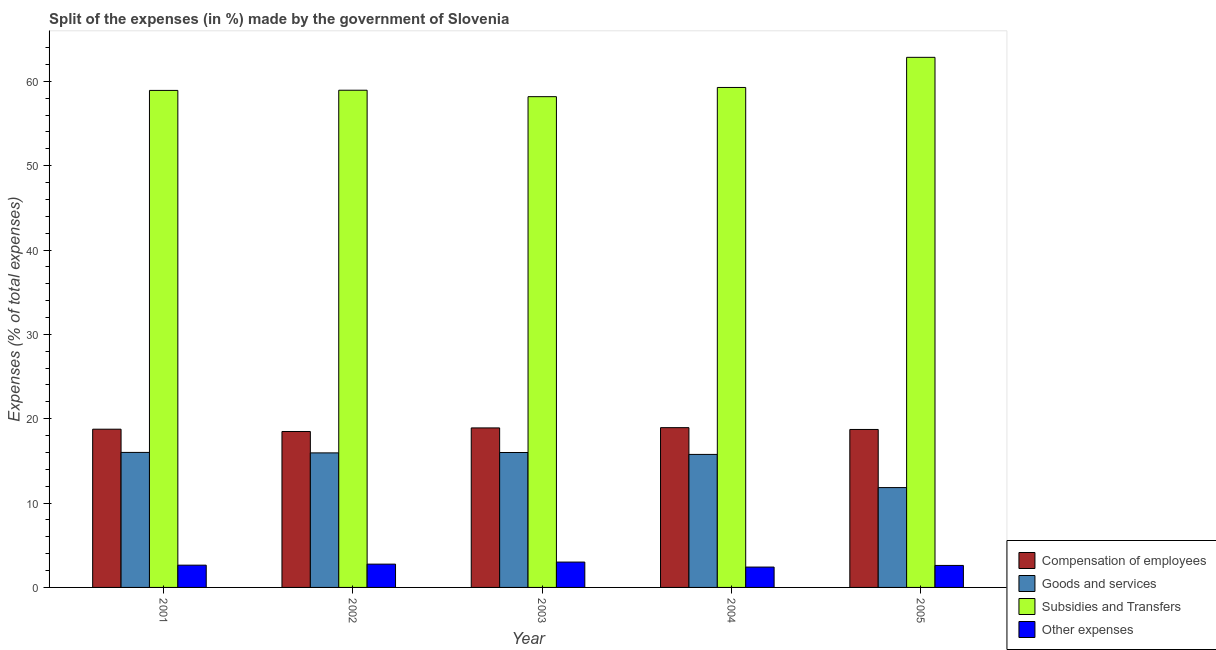Are the number of bars per tick equal to the number of legend labels?
Give a very brief answer. Yes. How many bars are there on the 1st tick from the left?
Your response must be concise. 4. What is the percentage of amount spent on compensation of employees in 2005?
Offer a terse response. 18.73. Across all years, what is the maximum percentage of amount spent on compensation of employees?
Provide a short and direct response. 18.94. Across all years, what is the minimum percentage of amount spent on compensation of employees?
Keep it short and to the point. 18.49. In which year was the percentage of amount spent on other expenses minimum?
Your answer should be very brief. 2004. What is the total percentage of amount spent on goods and services in the graph?
Make the answer very short. 75.55. What is the difference between the percentage of amount spent on other expenses in 2002 and that in 2003?
Provide a succinct answer. -0.24. What is the difference between the percentage of amount spent on compensation of employees in 2005 and the percentage of amount spent on subsidies in 2004?
Ensure brevity in your answer.  -0.21. What is the average percentage of amount spent on subsidies per year?
Give a very brief answer. 59.63. In the year 2002, what is the difference between the percentage of amount spent on subsidies and percentage of amount spent on compensation of employees?
Your response must be concise. 0. What is the ratio of the percentage of amount spent on other expenses in 2003 to that in 2005?
Offer a very short reply. 1.15. Is the percentage of amount spent on goods and services in 2001 less than that in 2004?
Your answer should be very brief. No. Is the difference between the percentage of amount spent on other expenses in 2001 and 2004 greater than the difference between the percentage of amount spent on subsidies in 2001 and 2004?
Your answer should be very brief. No. What is the difference between the highest and the second highest percentage of amount spent on goods and services?
Your answer should be very brief. 0.01. What is the difference between the highest and the lowest percentage of amount spent on compensation of employees?
Ensure brevity in your answer.  0.45. In how many years, is the percentage of amount spent on other expenses greater than the average percentage of amount spent on other expenses taken over all years?
Your answer should be compact. 2. What does the 2nd bar from the left in 2001 represents?
Make the answer very short. Goods and services. What does the 4th bar from the right in 2001 represents?
Provide a short and direct response. Compensation of employees. Is it the case that in every year, the sum of the percentage of amount spent on compensation of employees and percentage of amount spent on goods and services is greater than the percentage of amount spent on subsidies?
Offer a very short reply. No. How many bars are there?
Give a very brief answer. 20. Are all the bars in the graph horizontal?
Provide a succinct answer. No. How many years are there in the graph?
Keep it short and to the point. 5. Are the values on the major ticks of Y-axis written in scientific E-notation?
Offer a terse response. No. Where does the legend appear in the graph?
Your response must be concise. Bottom right. What is the title of the graph?
Offer a terse response. Split of the expenses (in %) made by the government of Slovenia. Does "Tertiary education" appear as one of the legend labels in the graph?
Ensure brevity in your answer.  No. What is the label or title of the X-axis?
Keep it short and to the point. Year. What is the label or title of the Y-axis?
Offer a very short reply. Expenses (% of total expenses). What is the Expenses (% of total expenses) in Compensation of employees in 2001?
Your answer should be compact. 18.76. What is the Expenses (% of total expenses) in Goods and services in 2001?
Your response must be concise. 16.01. What is the Expenses (% of total expenses) in Subsidies and Transfers in 2001?
Your answer should be compact. 58.92. What is the Expenses (% of total expenses) of Other expenses in 2001?
Offer a terse response. 2.64. What is the Expenses (% of total expenses) of Compensation of employees in 2002?
Keep it short and to the point. 18.49. What is the Expenses (% of total expenses) of Goods and services in 2002?
Provide a short and direct response. 15.95. What is the Expenses (% of total expenses) in Subsidies and Transfers in 2002?
Offer a terse response. 58.94. What is the Expenses (% of total expenses) in Other expenses in 2002?
Make the answer very short. 2.76. What is the Expenses (% of total expenses) in Compensation of employees in 2003?
Keep it short and to the point. 18.91. What is the Expenses (% of total expenses) in Goods and services in 2003?
Your response must be concise. 15.99. What is the Expenses (% of total expenses) of Subsidies and Transfers in 2003?
Offer a terse response. 58.18. What is the Expenses (% of total expenses) in Other expenses in 2003?
Your answer should be very brief. 3.01. What is the Expenses (% of total expenses) of Compensation of employees in 2004?
Offer a terse response. 18.94. What is the Expenses (% of total expenses) in Goods and services in 2004?
Provide a succinct answer. 15.77. What is the Expenses (% of total expenses) in Subsidies and Transfers in 2004?
Provide a short and direct response. 59.27. What is the Expenses (% of total expenses) of Other expenses in 2004?
Provide a succinct answer. 2.41. What is the Expenses (% of total expenses) of Compensation of employees in 2005?
Make the answer very short. 18.73. What is the Expenses (% of total expenses) in Goods and services in 2005?
Your answer should be very brief. 11.83. What is the Expenses (% of total expenses) in Subsidies and Transfers in 2005?
Your answer should be compact. 62.84. What is the Expenses (% of total expenses) of Other expenses in 2005?
Offer a terse response. 2.61. Across all years, what is the maximum Expenses (% of total expenses) of Compensation of employees?
Keep it short and to the point. 18.94. Across all years, what is the maximum Expenses (% of total expenses) in Goods and services?
Offer a terse response. 16.01. Across all years, what is the maximum Expenses (% of total expenses) in Subsidies and Transfers?
Your answer should be compact. 62.84. Across all years, what is the maximum Expenses (% of total expenses) in Other expenses?
Ensure brevity in your answer.  3.01. Across all years, what is the minimum Expenses (% of total expenses) in Compensation of employees?
Your answer should be compact. 18.49. Across all years, what is the minimum Expenses (% of total expenses) of Goods and services?
Make the answer very short. 11.83. Across all years, what is the minimum Expenses (% of total expenses) in Subsidies and Transfers?
Offer a very short reply. 58.18. Across all years, what is the minimum Expenses (% of total expenses) in Other expenses?
Offer a terse response. 2.41. What is the total Expenses (% of total expenses) of Compensation of employees in the graph?
Your response must be concise. 93.82. What is the total Expenses (% of total expenses) of Goods and services in the graph?
Ensure brevity in your answer.  75.55. What is the total Expenses (% of total expenses) of Subsidies and Transfers in the graph?
Make the answer very short. 298.15. What is the total Expenses (% of total expenses) in Other expenses in the graph?
Give a very brief answer. 13.43. What is the difference between the Expenses (% of total expenses) of Compensation of employees in 2001 and that in 2002?
Ensure brevity in your answer.  0.27. What is the difference between the Expenses (% of total expenses) of Goods and services in 2001 and that in 2002?
Your answer should be very brief. 0.06. What is the difference between the Expenses (% of total expenses) of Subsidies and Transfers in 2001 and that in 2002?
Make the answer very short. -0.02. What is the difference between the Expenses (% of total expenses) of Other expenses in 2001 and that in 2002?
Provide a short and direct response. -0.12. What is the difference between the Expenses (% of total expenses) in Compensation of employees in 2001 and that in 2003?
Make the answer very short. -0.15. What is the difference between the Expenses (% of total expenses) in Goods and services in 2001 and that in 2003?
Your response must be concise. 0.01. What is the difference between the Expenses (% of total expenses) of Subsidies and Transfers in 2001 and that in 2003?
Your response must be concise. 0.74. What is the difference between the Expenses (% of total expenses) in Other expenses in 2001 and that in 2003?
Make the answer very short. -0.37. What is the difference between the Expenses (% of total expenses) of Compensation of employees in 2001 and that in 2004?
Offer a very short reply. -0.18. What is the difference between the Expenses (% of total expenses) in Goods and services in 2001 and that in 2004?
Your answer should be very brief. 0.24. What is the difference between the Expenses (% of total expenses) in Subsidies and Transfers in 2001 and that in 2004?
Your response must be concise. -0.35. What is the difference between the Expenses (% of total expenses) of Other expenses in 2001 and that in 2004?
Offer a terse response. 0.22. What is the difference between the Expenses (% of total expenses) in Compensation of employees in 2001 and that in 2005?
Give a very brief answer. 0.03. What is the difference between the Expenses (% of total expenses) of Goods and services in 2001 and that in 2005?
Give a very brief answer. 4.17. What is the difference between the Expenses (% of total expenses) in Subsidies and Transfers in 2001 and that in 2005?
Provide a succinct answer. -3.92. What is the difference between the Expenses (% of total expenses) in Other expenses in 2001 and that in 2005?
Provide a short and direct response. 0.03. What is the difference between the Expenses (% of total expenses) of Compensation of employees in 2002 and that in 2003?
Provide a succinct answer. -0.42. What is the difference between the Expenses (% of total expenses) of Goods and services in 2002 and that in 2003?
Keep it short and to the point. -0.05. What is the difference between the Expenses (% of total expenses) in Subsidies and Transfers in 2002 and that in 2003?
Keep it short and to the point. 0.76. What is the difference between the Expenses (% of total expenses) of Other expenses in 2002 and that in 2003?
Make the answer very short. -0.24. What is the difference between the Expenses (% of total expenses) in Compensation of employees in 2002 and that in 2004?
Your answer should be compact. -0.45. What is the difference between the Expenses (% of total expenses) in Goods and services in 2002 and that in 2004?
Your answer should be compact. 0.18. What is the difference between the Expenses (% of total expenses) of Subsidies and Transfers in 2002 and that in 2004?
Your answer should be very brief. -0.33. What is the difference between the Expenses (% of total expenses) of Other expenses in 2002 and that in 2004?
Ensure brevity in your answer.  0.35. What is the difference between the Expenses (% of total expenses) in Compensation of employees in 2002 and that in 2005?
Provide a succinct answer. -0.24. What is the difference between the Expenses (% of total expenses) of Goods and services in 2002 and that in 2005?
Make the answer very short. 4.11. What is the difference between the Expenses (% of total expenses) in Subsidies and Transfers in 2002 and that in 2005?
Ensure brevity in your answer.  -3.9. What is the difference between the Expenses (% of total expenses) of Other expenses in 2002 and that in 2005?
Your response must be concise. 0.15. What is the difference between the Expenses (% of total expenses) in Compensation of employees in 2003 and that in 2004?
Offer a very short reply. -0.03. What is the difference between the Expenses (% of total expenses) of Goods and services in 2003 and that in 2004?
Offer a very short reply. 0.23. What is the difference between the Expenses (% of total expenses) of Subsidies and Transfers in 2003 and that in 2004?
Provide a short and direct response. -1.09. What is the difference between the Expenses (% of total expenses) in Other expenses in 2003 and that in 2004?
Give a very brief answer. 0.59. What is the difference between the Expenses (% of total expenses) in Compensation of employees in 2003 and that in 2005?
Offer a very short reply. 0.18. What is the difference between the Expenses (% of total expenses) in Goods and services in 2003 and that in 2005?
Provide a short and direct response. 4.16. What is the difference between the Expenses (% of total expenses) in Subsidies and Transfers in 2003 and that in 2005?
Provide a short and direct response. -4.66. What is the difference between the Expenses (% of total expenses) of Other expenses in 2003 and that in 2005?
Make the answer very short. 0.4. What is the difference between the Expenses (% of total expenses) in Compensation of employees in 2004 and that in 2005?
Give a very brief answer. 0.21. What is the difference between the Expenses (% of total expenses) in Goods and services in 2004 and that in 2005?
Your answer should be very brief. 3.93. What is the difference between the Expenses (% of total expenses) of Subsidies and Transfers in 2004 and that in 2005?
Give a very brief answer. -3.57. What is the difference between the Expenses (% of total expenses) of Other expenses in 2004 and that in 2005?
Give a very brief answer. -0.19. What is the difference between the Expenses (% of total expenses) in Compensation of employees in 2001 and the Expenses (% of total expenses) in Goods and services in 2002?
Keep it short and to the point. 2.81. What is the difference between the Expenses (% of total expenses) in Compensation of employees in 2001 and the Expenses (% of total expenses) in Subsidies and Transfers in 2002?
Keep it short and to the point. -40.19. What is the difference between the Expenses (% of total expenses) of Compensation of employees in 2001 and the Expenses (% of total expenses) of Other expenses in 2002?
Provide a short and direct response. 16. What is the difference between the Expenses (% of total expenses) in Goods and services in 2001 and the Expenses (% of total expenses) in Subsidies and Transfers in 2002?
Provide a succinct answer. -42.94. What is the difference between the Expenses (% of total expenses) of Goods and services in 2001 and the Expenses (% of total expenses) of Other expenses in 2002?
Offer a very short reply. 13.24. What is the difference between the Expenses (% of total expenses) of Subsidies and Transfers in 2001 and the Expenses (% of total expenses) of Other expenses in 2002?
Make the answer very short. 56.16. What is the difference between the Expenses (% of total expenses) in Compensation of employees in 2001 and the Expenses (% of total expenses) in Goods and services in 2003?
Provide a short and direct response. 2.76. What is the difference between the Expenses (% of total expenses) in Compensation of employees in 2001 and the Expenses (% of total expenses) in Subsidies and Transfers in 2003?
Ensure brevity in your answer.  -39.42. What is the difference between the Expenses (% of total expenses) of Compensation of employees in 2001 and the Expenses (% of total expenses) of Other expenses in 2003?
Your answer should be compact. 15.75. What is the difference between the Expenses (% of total expenses) of Goods and services in 2001 and the Expenses (% of total expenses) of Subsidies and Transfers in 2003?
Ensure brevity in your answer.  -42.17. What is the difference between the Expenses (% of total expenses) in Goods and services in 2001 and the Expenses (% of total expenses) in Other expenses in 2003?
Give a very brief answer. 13. What is the difference between the Expenses (% of total expenses) in Subsidies and Transfers in 2001 and the Expenses (% of total expenses) in Other expenses in 2003?
Offer a very short reply. 55.91. What is the difference between the Expenses (% of total expenses) of Compensation of employees in 2001 and the Expenses (% of total expenses) of Goods and services in 2004?
Keep it short and to the point. 2.99. What is the difference between the Expenses (% of total expenses) in Compensation of employees in 2001 and the Expenses (% of total expenses) in Subsidies and Transfers in 2004?
Make the answer very short. -40.51. What is the difference between the Expenses (% of total expenses) of Compensation of employees in 2001 and the Expenses (% of total expenses) of Other expenses in 2004?
Keep it short and to the point. 16.34. What is the difference between the Expenses (% of total expenses) of Goods and services in 2001 and the Expenses (% of total expenses) of Subsidies and Transfers in 2004?
Keep it short and to the point. -43.26. What is the difference between the Expenses (% of total expenses) of Goods and services in 2001 and the Expenses (% of total expenses) of Other expenses in 2004?
Ensure brevity in your answer.  13.59. What is the difference between the Expenses (% of total expenses) in Subsidies and Transfers in 2001 and the Expenses (% of total expenses) in Other expenses in 2004?
Provide a succinct answer. 56.5. What is the difference between the Expenses (% of total expenses) of Compensation of employees in 2001 and the Expenses (% of total expenses) of Goods and services in 2005?
Provide a short and direct response. 6.92. What is the difference between the Expenses (% of total expenses) in Compensation of employees in 2001 and the Expenses (% of total expenses) in Subsidies and Transfers in 2005?
Keep it short and to the point. -44.08. What is the difference between the Expenses (% of total expenses) of Compensation of employees in 2001 and the Expenses (% of total expenses) of Other expenses in 2005?
Keep it short and to the point. 16.15. What is the difference between the Expenses (% of total expenses) in Goods and services in 2001 and the Expenses (% of total expenses) in Subsidies and Transfers in 2005?
Your answer should be compact. -46.84. What is the difference between the Expenses (% of total expenses) in Goods and services in 2001 and the Expenses (% of total expenses) in Other expenses in 2005?
Offer a very short reply. 13.4. What is the difference between the Expenses (% of total expenses) in Subsidies and Transfers in 2001 and the Expenses (% of total expenses) in Other expenses in 2005?
Offer a terse response. 56.31. What is the difference between the Expenses (% of total expenses) of Compensation of employees in 2002 and the Expenses (% of total expenses) of Goods and services in 2003?
Provide a succinct answer. 2.49. What is the difference between the Expenses (% of total expenses) of Compensation of employees in 2002 and the Expenses (% of total expenses) of Subsidies and Transfers in 2003?
Make the answer very short. -39.69. What is the difference between the Expenses (% of total expenses) of Compensation of employees in 2002 and the Expenses (% of total expenses) of Other expenses in 2003?
Offer a very short reply. 15.48. What is the difference between the Expenses (% of total expenses) in Goods and services in 2002 and the Expenses (% of total expenses) in Subsidies and Transfers in 2003?
Offer a terse response. -42.23. What is the difference between the Expenses (% of total expenses) in Goods and services in 2002 and the Expenses (% of total expenses) in Other expenses in 2003?
Offer a terse response. 12.94. What is the difference between the Expenses (% of total expenses) of Subsidies and Transfers in 2002 and the Expenses (% of total expenses) of Other expenses in 2003?
Make the answer very short. 55.94. What is the difference between the Expenses (% of total expenses) of Compensation of employees in 2002 and the Expenses (% of total expenses) of Goods and services in 2004?
Give a very brief answer. 2.72. What is the difference between the Expenses (% of total expenses) in Compensation of employees in 2002 and the Expenses (% of total expenses) in Subsidies and Transfers in 2004?
Make the answer very short. -40.78. What is the difference between the Expenses (% of total expenses) of Compensation of employees in 2002 and the Expenses (% of total expenses) of Other expenses in 2004?
Ensure brevity in your answer.  16.07. What is the difference between the Expenses (% of total expenses) of Goods and services in 2002 and the Expenses (% of total expenses) of Subsidies and Transfers in 2004?
Make the answer very short. -43.32. What is the difference between the Expenses (% of total expenses) in Goods and services in 2002 and the Expenses (% of total expenses) in Other expenses in 2004?
Provide a short and direct response. 13.53. What is the difference between the Expenses (% of total expenses) of Subsidies and Transfers in 2002 and the Expenses (% of total expenses) of Other expenses in 2004?
Keep it short and to the point. 56.53. What is the difference between the Expenses (% of total expenses) in Compensation of employees in 2002 and the Expenses (% of total expenses) in Goods and services in 2005?
Keep it short and to the point. 6.65. What is the difference between the Expenses (% of total expenses) of Compensation of employees in 2002 and the Expenses (% of total expenses) of Subsidies and Transfers in 2005?
Your answer should be compact. -44.35. What is the difference between the Expenses (% of total expenses) in Compensation of employees in 2002 and the Expenses (% of total expenses) in Other expenses in 2005?
Your response must be concise. 15.88. What is the difference between the Expenses (% of total expenses) in Goods and services in 2002 and the Expenses (% of total expenses) in Subsidies and Transfers in 2005?
Your response must be concise. -46.89. What is the difference between the Expenses (% of total expenses) of Goods and services in 2002 and the Expenses (% of total expenses) of Other expenses in 2005?
Provide a short and direct response. 13.34. What is the difference between the Expenses (% of total expenses) in Subsidies and Transfers in 2002 and the Expenses (% of total expenses) in Other expenses in 2005?
Ensure brevity in your answer.  56.33. What is the difference between the Expenses (% of total expenses) in Compensation of employees in 2003 and the Expenses (% of total expenses) in Goods and services in 2004?
Make the answer very short. 3.14. What is the difference between the Expenses (% of total expenses) of Compensation of employees in 2003 and the Expenses (% of total expenses) of Subsidies and Transfers in 2004?
Keep it short and to the point. -40.36. What is the difference between the Expenses (% of total expenses) in Compensation of employees in 2003 and the Expenses (% of total expenses) in Other expenses in 2004?
Provide a short and direct response. 16.5. What is the difference between the Expenses (% of total expenses) in Goods and services in 2003 and the Expenses (% of total expenses) in Subsidies and Transfers in 2004?
Your answer should be compact. -43.27. What is the difference between the Expenses (% of total expenses) in Goods and services in 2003 and the Expenses (% of total expenses) in Other expenses in 2004?
Provide a short and direct response. 13.58. What is the difference between the Expenses (% of total expenses) in Subsidies and Transfers in 2003 and the Expenses (% of total expenses) in Other expenses in 2004?
Provide a succinct answer. 55.76. What is the difference between the Expenses (% of total expenses) in Compensation of employees in 2003 and the Expenses (% of total expenses) in Goods and services in 2005?
Give a very brief answer. 7.07. What is the difference between the Expenses (% of total expenses) in Compensation of employees in 2003 and the Expenses (% of total expenses) in Subsidies and Transfers in 2005?
Provide a short and direct response. -43.93. What is the difference between the Expenses (% of total expenses) of Compensation of employees in 2003 and the Expenses (% of total expenses) of Other expenses in 2005?
Provide a short and direct response. 16.3. What is the difference between the Expenses (% of total expenses) of Goods and services in 2003 and the Expenses (% of total expenses) of Subsidies and Transfers in 2005?
Provide a short and direct response. -46.85. What is the difference between the Expenses (% of total expenses) of Goods and services in 2003 and the Expenses (% of total expenses) of Other expenses in 2005?
Provide a succinct answer. 13.39. What is the difference between the Expenses (% of total expenses) in Subsidies and Transfers in 2003 and the Expenses (% of total expenses) in Other expenses in 2005?
Keep it short and to the point. 55.57. What is the difference between the Expenses (% of total expenses) in Compensation of employees in 2004 and the Expenses (% of total expenses) in Goods and services in 2005?
Your response must be concise. 7.11. What is the difference between the Expenses (% of total expenses) in Compensation of employees in 2004 and the Expenses (% of total expenses) in Subsidies and Transfers in 2005?
Give a very brief answer. -43.9. What is the difference between the Expenses (% of total expenses) in Compensation of employees in 2004 and the Expenses (% of total expenses) in Other expenses in 2005?
Provide a short and direct response. 16.33. What is the difference between the Expenses (% of total expenses) of Goods and services in 2004 and the Expenses (% of total expenses) of Subsidies and Transfers in 2005?
Your answer should be very brief. -47.07. What is the difference between the Expenses (% of total expenses) of Goods and services in 2004 and the Expenses (% of total expenses) of Other expenses in 2005?
Offer a very short reply. 13.16. What is the difference between the Expenses (% of total expenses) in Subsidies and Transfers in 2004 and the Expenses (% of total expenses) in Other expenses in 2005?
Give a very brief answer. 56.66. What is the average Expenses (% of total expenses) in Compensation of employees per year?
Offer a terse response. 18.76. What is the average Expenses (% of total expenses) in Goods and services per year?
Ensure brevity in your answer.  15.11. What is the average Expenses (% of total expenses) in Subsidies and Transfers per year?
Provide a short and direct response. 59.63. What is the average Expenses (% of total expenses) of Other expenses per year?
Offer a terse response. 2.69. In the year 2001, what is the difference between the Expenses (% of total expenses) of Compensation of employees and Expenses (% of total expenses) of Goods and services?
Your answer should be compact. 2.75. In the year 2001, what is the difference between the Expenses (% of total expenses) of Compensation of employees and Expenses (% of total expenses) of Subsidies and Transfers?
Provide a short and direct response. -40.16. In the year 2001, what is the difference between the Expenses (% of total expenses) of Compensation of employees and Expenses (% of total expenses) of Other expenses?
Give a very brief answer. 16.12. In the year 2001, what is the difference between the Expenses (% of total expenses) in Goods and services and Expenses (% of total expenses) in Subsidies and Transfers?
Provide a short and direct response. -42.91. In the year 2001, what is the difference between the Expenses (% of total expenses) of Goods and services and Expenses (% of total expenses) of Other expenses?
Your answer should be compact. 13.37. In the year 2001, what is the difference between the Expenses (% of total expenses) of Subsidies and Transfers and Expenses (% of total expenses) of Other expenses?
Offer a terse response. 56.28. In the year 2002, what is the difference between the Expenses (% of total expenses) in Compensation of employees and Expenses (% of total expenses) in Goods and services?
Give a very brief answer. 2.54. In the year 2002, what is the difference between the Expenses (% of total expenses) in Compensation of employees and Expenses (% of total expenses) in Subsidies and Transfers?
Ensure brevity in your answer.  -40.46. In the year 2002, what is the difference between the Expenses (% of total expenses) of Compensation of employees and Expenses (% of total expenses) of Other expenses?
Keep it short and to the point. 15.72. In the year 2002, what is the difference between the Expenses (% of total expenses) in Goods and services and Expenses (% of total expenses) in Subsidies and Transfers?
Provide a succinct answer. -42.99. In the year 2002, what is the difference between the Expenses (% of total expenses) of Goods and services and Expenses (% of total expenses) of Other expenses?
Your answer should be very brief. 13.19. In the year 2002, what is the difference between the Expenses (% of total expenses) in Subsidies and Transfers and Expenses (% of total expenses) in Other expenses?
Your response must be concise. 56.18. In the year 2003, what is the difference between the Expenses (% of total expenses) in Compensation of employees and Expenses (% of total expenses) in Goods and services?
Ensure brevity in your answer.  2.92. In the year 2003, what is the difference between the Expenses (% of total expenses) in Compensation of employees and Expenses (% of total expenses) in Subsidies and Transfers?
Your answer should be very brief. -39.27. In the year 2003, what is the difference between the Expenses (% of total expenses) of Compensation of employees and Expenses (% of total expenses) of Other expenses?
Give a very brief answer. 15.9. In the year 2003, what is the difference between the Expenses (% of total expenses) in Goods and services and Expenses (% of total expenses) in Subsidies and Transfers?
Keep it short and to the point. -42.18. In the year 2003, what is the difference between the Expenses (% of total expenses) of Goods and services and Expenses (% of total expenses) of Other expenses?
Your answer should be very brief. 12.99. In the year 2003, what is the difference between the Expenses (% of total expenses) in Subsidies and Transfers and Expenses (% of total expenses) in Other expenses?
Ensure brevity in your answer.  55.17. In the year 2004, what is the difference between the Expenses (% of total expenses) of Compensation of employees and Expenses (% of total expenses) of Goods and services?
Your answer should be compact. 3.17. In the year 2004, what is the difference between the Expenses (% of total expenses) in Compensation of employees and Expenses (% of total expenses) in Subsidies and Transfers?
Give a very brief answer. -40.33. In the year 2004, what is the difference between the Expenses (% of total expenses) of Compensation of employees and Expenses (% of total expenses) of Other expenses?
Ensure brevity in your answer.  16.53. In the year 2004, what is the difference between the Expenses (% of total expenses) of Goods and services and Expenses (% of total expenses) of Subsidies and Transfers?
Provide a short and direct response. -43.5. In the year 2004, what is the difference between the Expenses (% of total expenses) in Goods and services and Expenses (% of total expenses) in Other expenses?
Make the answer very short. 13.35. In the year 2004, what is the difference between the Expenses (% of total expenses) in Subsidies and Transfers and Expenses (% of total expenses) in Other expenses?
Keep it short and to the point. 56.85. In the year 2005, what is the difference between the Expenses (% of total expenses) of Compensation of employees and Expenses (% of total expenses) of Goods and services?
Provide a short and direct response. 6.89. In the year 2005, what is the difference between the Expenses (% of total expenses) of Compensation of employees and Expenses (% of total expenses) of Subsidies and Transfers?
Keep it short and to the point. -44.12. In the year 2005, what is the difference between the Expenses (% of total expenses) of Compensation of employees and Expenses (% of total expenses) of Other expenses?
Give a very brief answer. 16.12. In the year 2005, what is the difference between the Expenses (% of total expenses) of Goods and services and Expenses (% of total expenses) of Subsidies and Transfers?
Ensure brevity in your answer.  -51.01. In the year 2005, what is the difference between the Expenses (% of total expenses) in Goods and services and Expenses (% of total expenses) in Other expenses?
Offer a terse response. 9.23. In the year 2005, what is the difference between the Expenses (% of total expenses) in Subsidies and Transfers and Expenses (% of total expenses) in Other expenses?
Give a very brief answer. 60.23. What is the ratio of the Expenses (% of total expenses) in Compensation of employees in 2001 to that in 2002?
Give a very brief answer. 1.01. What is the ratio of the Expenses (% of total expenses) in Goods and services in 2001 to that in 2002?
Make the answer very short. 1. What is the ratio of the Expenses (% of total expenses) in Subsidies and Transfers in 2001 to that in 2002?
Your answer should be very brief. 1. What is the ratio of the Expenses (% of total expenses) of Other expenses in 2001 to that in 2002?
Keep it short and to the point. 0.96. What is the ratio of the Expenses (% of total expenses) in Goods and services in 2001 to that in 2003?
Provide a short and direct response. 1. What is the ratio of the Expenses (% of total expenses) of Subsidies and Transfers in 2001 to that in 2003?
Ensure brevity in your answer.  1.01. What is the ratio of the Expenses (% of total expenses) in Other expenses in 2001 to that in 2003?
Your answer should be compact. 0.88. What is the ratio of the Expenses (% of total expenses) of Compensation of employees in 2001 to that in 2004?
Your answer should be very brief. 0.99. What is the ratio of the Expenses (% of total expenses) of Other expenses in 2001 to that in 2004?
Offer a very short reply. 1.09. What is the ratio of the Expenses (% of total expenses) of Compensation of employees in 2001 to that in 2005?
Your response must be concise. 1. What is the ratio of the Expenses (% of total expenses) in Goods and services in 2001 to that in 2005?
Provide a short and direct response. 1.35. What is the ratio of the Expenses (% of total expenses) in Subsidies and Transfers in 2001 to that in 2005?
Your response must be concise. 0.94. What is the ratio of the Expenses (% of total expenses) of Other expenses in 2001 to that in 2005?
Offer a very short reply. 1.01. What is the ratio of the Expenses (% of total expenses) of Compensation of employees in 2002 to that in 2003?
Your answer should be very brief. 0.98. What is the ratio of the Expenses (% of total expenses) in Goods and services in 2002 to that in 2003?
Keep it short and to the point. 1. What is the ratio of the Expenses (% of total expenses) in Subsidies and Transfers in 2002 to that in 2003?
Your answer should be compact. 1.01. What is the ratio of the Expenses (% of total expenses) in Other expenses in 2002 to that in 2003?
Give a very brief answer. 0.92. What is the ratio of the Expenses (% of total expenses) of Compensation of employees in 2002 to that in 2004?
Offer a very short reply. 0.98. What is the ratio of the Expenses (% of total expenses) in Goods and services in 2002 to that in 2004?
Your answer should be compact. 1.01. What is the ratio of the Expenses (% of total expenses) in Other expenses in 2002 to that in 2004?
Offer a very short reply. 1.14. What is the ratio of the Expenses (% of total expenses) of Compensation of employees in 2002 to that in 2005?
Provide a succinct answer. 0.99. What is the ratio of the Expenses (% of total expenses) in Goods and services in 2002 to that in 2005?
Offer a terse response. 1.35. What is the ratio of the Expenses (% of total expenses) in Subsidies and Transfers in 2002 to that in 2005?
Keep it short and to the point. 0.94. What is the ratio of the Expenses (% of total expenses) in Other expenses in 2002 to that in 2005?
Your response must be concise. 1.06. What is the ratio of the Expenses (% of total expenses) of Goods and services in 2003 to that in 2004?
Provide a short and direct response. 1.01. What is the ratio of the Expenses (% of total expenses) in Subsidies and Transfers in 2003 to that in 2004?
Provide a succinct answer. 0.98. What is the ratio of the Expenses (% of total expenses) in Other expenses in 2003 to that in 2004?
Provide a succinct answer. 1.25. What is the ratio of the Expenses (% of total expenses) in Compensation of employees in 2003 to that in 2005?
Make the answer very short. 1.01. What is the ratio of the Expenses (% of total expenses) of Goods and services in 2003 to that in 2005?
Provide a succinct answer. 1.35. What is the ratio of the Expenses (% of total expenses) in Subsidies and Transfers in 2003 to that in 2005?
Make the answer very short. 0.93. What is the ratio of the Expenses (% of total expenses) in Other expenses in 2003 to that in 2005?
Provide a short and direct response. 1.15. What is the ratio of the Expenses (% of total expenses) of Compensation of employees in 2004 to that in 2005?
Provide a succinct answer. 1.01. What is the ratio of the Expenses (% of total expenses) in Goods and services in 2004 to that in 2005?
Ensure brevity in your answer.  1.33. What is the ratio of the Expenses (% of total expenses) in Subsidies and Transfers in 2004 to that in 2005?
Make the answer very short. 0.94. What is the ratio of the Expenses (% of total expenses) in Other expenses in 2004 to that in 2005?
Give a very brief answer. 0.93. What is the difference between the highest and the second highest Expenses (% of total expenses) of Compensation of employees?
Your response must be concise. 0.03. What is the difference between the highest and the second highest Expenses (% of total expenses) of Goods and services?
Offer a terse response. 0.01. What is the difference between the highest and the second highest Expenses (% of total expenses) in Subsidies and Transfers?
Offer a terse response. 3.57. What is the difference between the highest and the second highest Expenses (% of total expenses) of Other expenses?
Offer a very short reply. 0.24. What is the difference between the highest and the lowest Expenses (% of total expenses) of Compensation of employees?
Give a very brief answer. 0.45. What is the difference between the highest and the lowest Expenses (% of total expenses) in Goods and services?
Your answer should be compact. 4.17. What is the difference between the highest and the lowest Expenses (% of total expenses) in Subsidies and Transfers?
Offer a very short reply. 4.66. What is the difference between the highest and the lowest Expenses (% of total expenses) in Other expenses?
Provide a short and direct response. 0.59. 